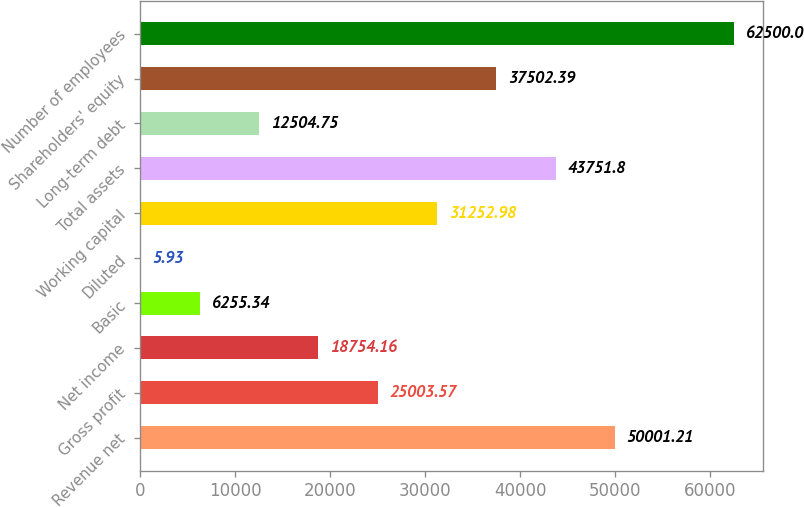Convert chart. <chart><loc_0><loc_0><loc_500><loc_500><bar_chart><fcel>Revenue net<fcel>Gross profit<fcel>Net income<fcel>Basic<fcel>Diluted<fcel>Working capital<fcel>Total assets<fcel>Long-term debt<fcel>Shareholders' equity<fcel>Number of employees<nl><fcel>50001.2<fcel>25003.6<fcel>18754.2<fcel>6255.34<fcel>5.93<fcel>31253<fcel>43751.8<fcel>12504.8<fcel>37502.4<fcel>62500<nl></chart> 